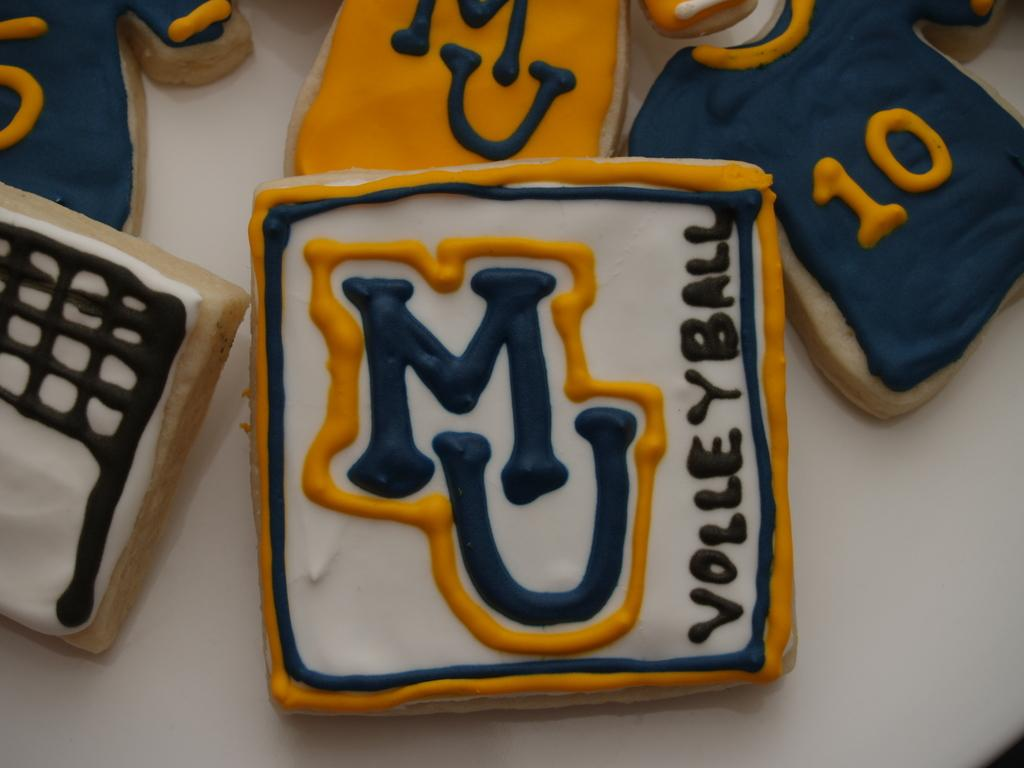<image>
Render a clear and concise summary of the photo. Cookies with Michigan University Volleyball team logos on them. 